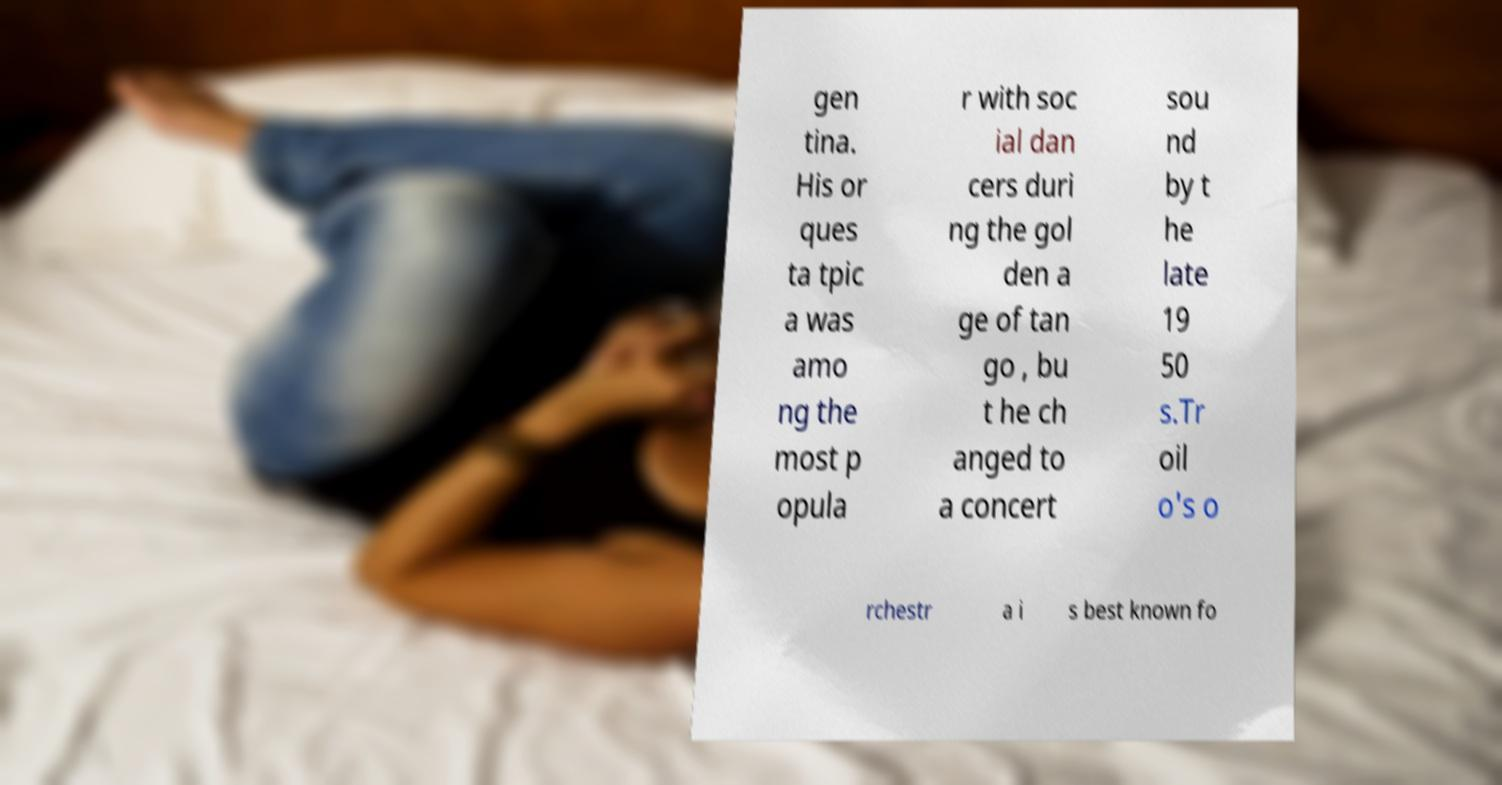For documentation purposes, I need the text within this image transcribed. Could you provide that? gen tina. His or ques ta tpic a was amo ng the most p opula r with soc ial dan cers duri ng the gol den a ge of tan go , bu t he ch anged to a concert sou nd by t he late 19 50 s.Tr oil o's o rchestr a i s best known fo 